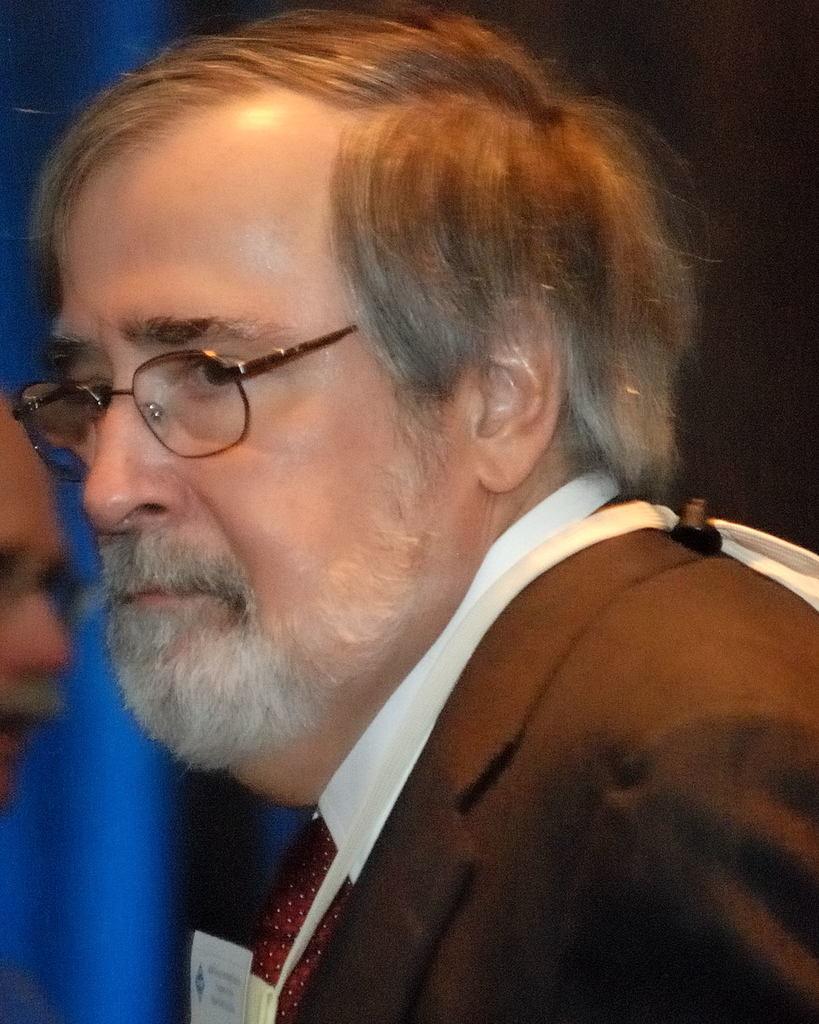In one or two sentences, can you explain what this image depicts? In the center of the image a man is wearing suit, tie, spectacles. On the left side of the image we can see person and blue light. In the background the image is dark. 